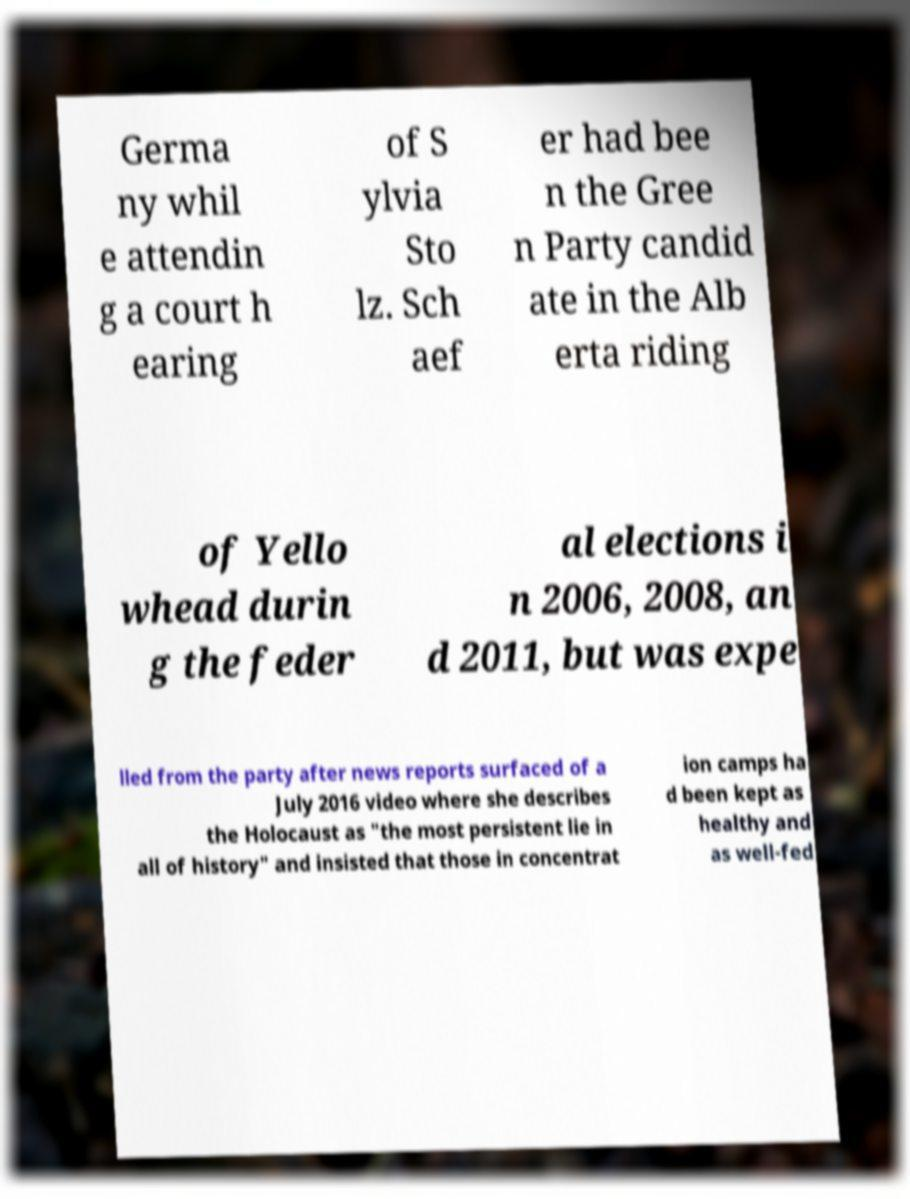Please identify and transcribe the text found in this image. Germa ny whil e attendin g a court h earing of S ylvia Sto lz. Sch aef er had bee n the Gree n Party candid ate in the Alb erta riding of Yello whead durin g the feder al elections i n 2006, 2008, an d 2011, but was expe lled from the party after news reports surfaced of a July 2016 video where she describes the Holocaust as "the most persistent lie in all of history" and insisted that those in concentrat ion camps ha d been kept as healthy and as well-fed 